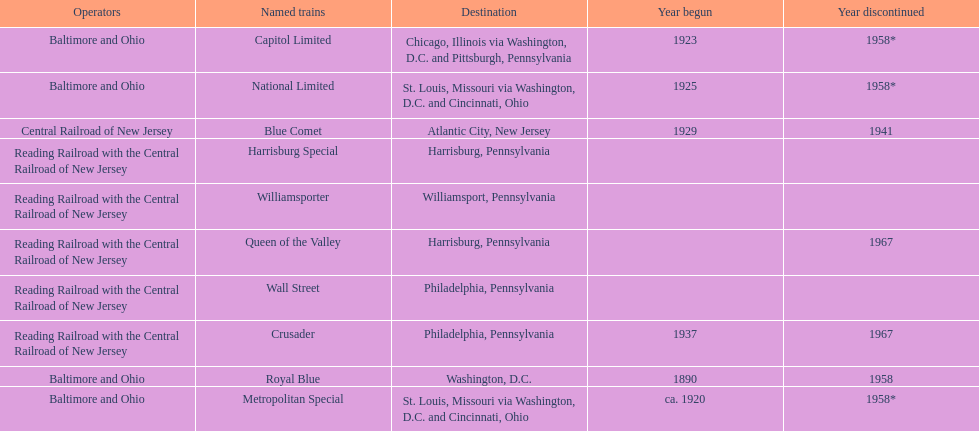Parse the table in full. {'header': ['Operators', 'Named trains', 'Destination', 'Year begun', 'Year discontinued'], 'rows': [['Baltimore and Ohio', 'Capitol Limited', 'Chicago, Illinois via Washington, D.C. and Pittsburgh, Pennsylvania', '1923', '1958*'], ['Baltimore and Ohio', 'National Limited', 'St. Louis, Missouri via Washington, D.C. and Cincinnati, Ohio', '1925', '1958*'], ['Central Railroad of New Jersey', 'Blue Comet', 'Atlantic City, New Jersey', '1929', '1941'], ['Reading Railroad with the Central Railroad of New Jersey', 'Harrisburg Special', 'Harrisburg, Pennsylvania', '', ''], ['Reading Railroad with the Central Railroad of New Jersey', 'Williamsporter', 'Williamsport, Pennsylvania', '', ''], ['Reading Railroad with the Central Railroad of New Jersey', 'Queen of the Valley', 'Harrisburg, Pennsylvania', '', '1967'], ['Reading Railroad with the Central Railroad of New Jersey', 'Wall Street', 'Philadelphia, Pennsylvania', '', ''], ['Reading Railroad with the Central Railroad of New Jersey', 'Crusader', 'Philadelphia, Pennsylvania', '1937', '1967'], ['Baltimore and Ohio', 'Royal Blue', 'Washington, D.C.', '1890', '1958'], ['Baltimore and Ohio', 'Metropolitan Special', 'St. Louis, Missouri via Washington, D.C. and Cincinnati, Ohio', 'ca. 1920', '1958*']]} Which other traine, other than wall street, had philadelphia as a destination? Crusader. 